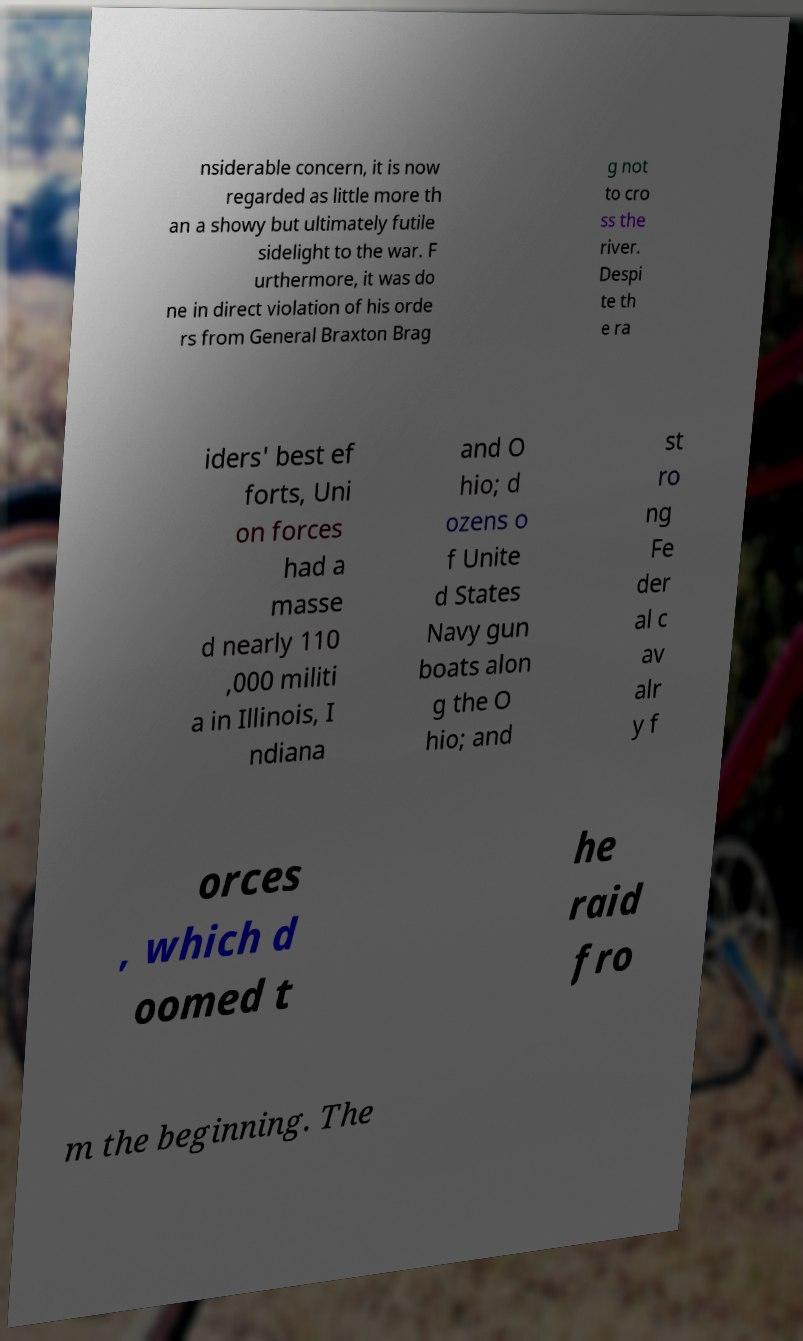Please identify and transcribe the text found in this image. nsiderable concern, it is now regarded as little more th an a showy but ultimately futile sidelight to the war. F urthermore, it was do ne in direct violation of his orde rs from General Braxton Brag g not to cro ss the river. Despi te th e ra iders' best ef forts, Uni on forces had a masse d nearly 110 ,000 militi a in Illinois, I ndiana and O hio; d ozens o f Unite d States Navy gun boats alon g the O hio; and st ro ng Fe der al c av alr y f orces , which d oomed t he raid fro m the beginning. The 